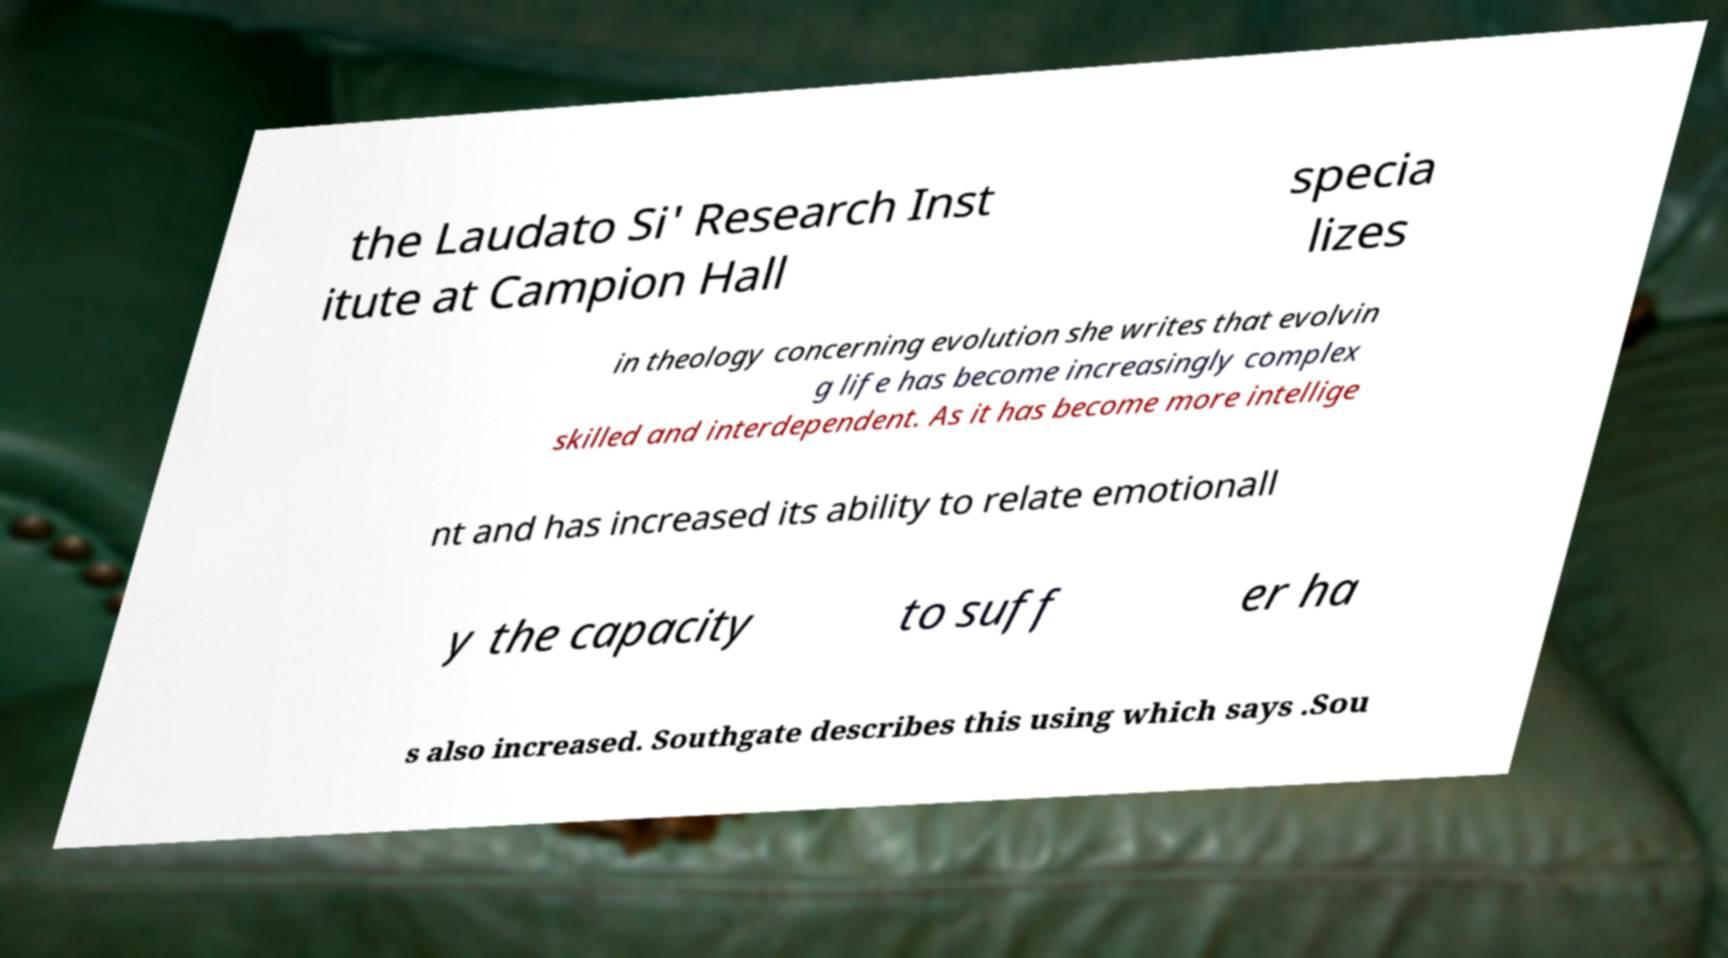I need the written content from this picture converted into text. Can you do that? the Laudato Si' Research Inst itute at Campion Hall specia lizes in theology concerning evolution she writes that evolvin g life has become increasingly complex skilled and interdependent. As it has become more intellige nt and has increased its ability to relate emotionall y the capacity to suff er ha s also increased. Southgate describes this using which says .Sou 